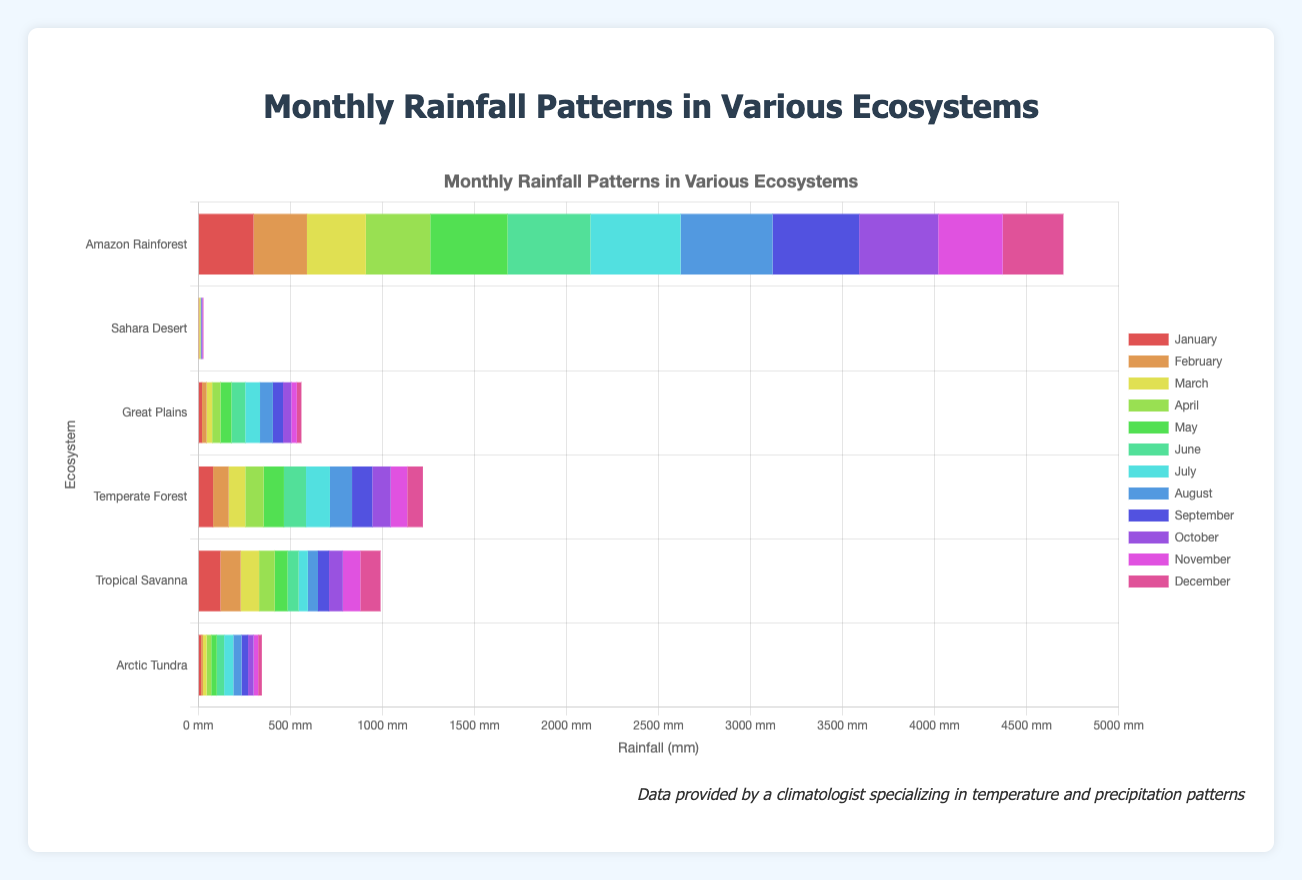Which ecosystem receives the highest total rainfall across all months? Sum the monthly rainfall for each ecosystem and identify the ecosystem with the highest total. For the Amazon Rainforest, the sum is: 300 + 290 + 320 + 350 + 420 + 450 + 490 + 500 + 470 + 430 + 350 + 330 = 4700 mm. For Sahara Desert, the sum is: 2 + 3 + 5 + 2 + 1 + 0 + 0 + 1 + 3 + 5 + 4 + 2 = 28 mm, and so forth. The Amazon Rainforest has the highest total rainfall.
Answer: Amazon Rainforest Which month sees the highest rainfall in the Great Plains? Look at the values for each month in the Great Plains row and identify the highest. The values are January: 20, February: 25, March: 30, April: 45, May: 60, June: 75, July: 80, August: 70, September: 55, October: 45, November: 30, December: 25. July has the highest value.
Answer: July Compare the rainfall amounts in the Amazon Rainforest and Sahara Desert for July. How many times greater is the rainfall in the Amazon Rainforest compared to the Sahara Desert? Look at the July values for both ecosystems. Amazon Rainforest is 490 mm, and Sahara Desert is 0 mm. Since the Sahara Desert has 0 mm of rainfall, the Amazon Rainforest has infinitely more rainfall in July.
Answer: Infinitely more What is the average monthly rainfall in the Temperate Forest? Sum the monthly rainfall values for the Temperate Forest and divide by 12. The values are: 80 + 85 + 90 + 100 + 110 + 120 + 130 + 120 + 110 + 100 + 90 + 85. The total is 1220, so the average is 1220 / 12 ≈ 101.67 mm.
Answer: 101.67 mm How does the annual rainfall of the Arctic Tundra compare to that of the Tropical Savanna? Sum the monthly rainfall for both ecosystems and compare. Arctic Tundra: 15 + 10 + 20 + 25 + 30 + 40 + 50 + 45 + 35 + 30 + 25 + 20 = 345 mm. Tropical Savanna: 120 + 110 + 100 + 85 + 70 + 60 + 50 + 55 + 60 + 75 + 95 + 110 = 990 mm. The Tropical Savanna has more annual rainfall.
Answer: Tropical Savanna Which ecosystem has the least rainfall in February? Compare the February rainfall values for each ecosystem: Amazon Rainforest: 290, Sahara Desert: 3, Great Plains: 25, Temperate Forest: 85, Tropical Savanna: 110, Arctic Tundra: 10. The Sahara Desert has the least rainfall.
Answer: Sahara Desert What color represents the month of December in the chart? Each month is represented by a specific color in the chart. December corresponds to the last dataset. Check the last dataset's background color, which is a shade determined by the color scale provided.
Answer: Identify based on color in figure If the total annual rainfall in the Temperate Forest increased by 20%, what would be the new total? The current total rainfall in the Temperate Forest is 1220 mm. Increasing by 20%: 1220 * 1.20 = 1464 mm.
Answer: 1464 mm 